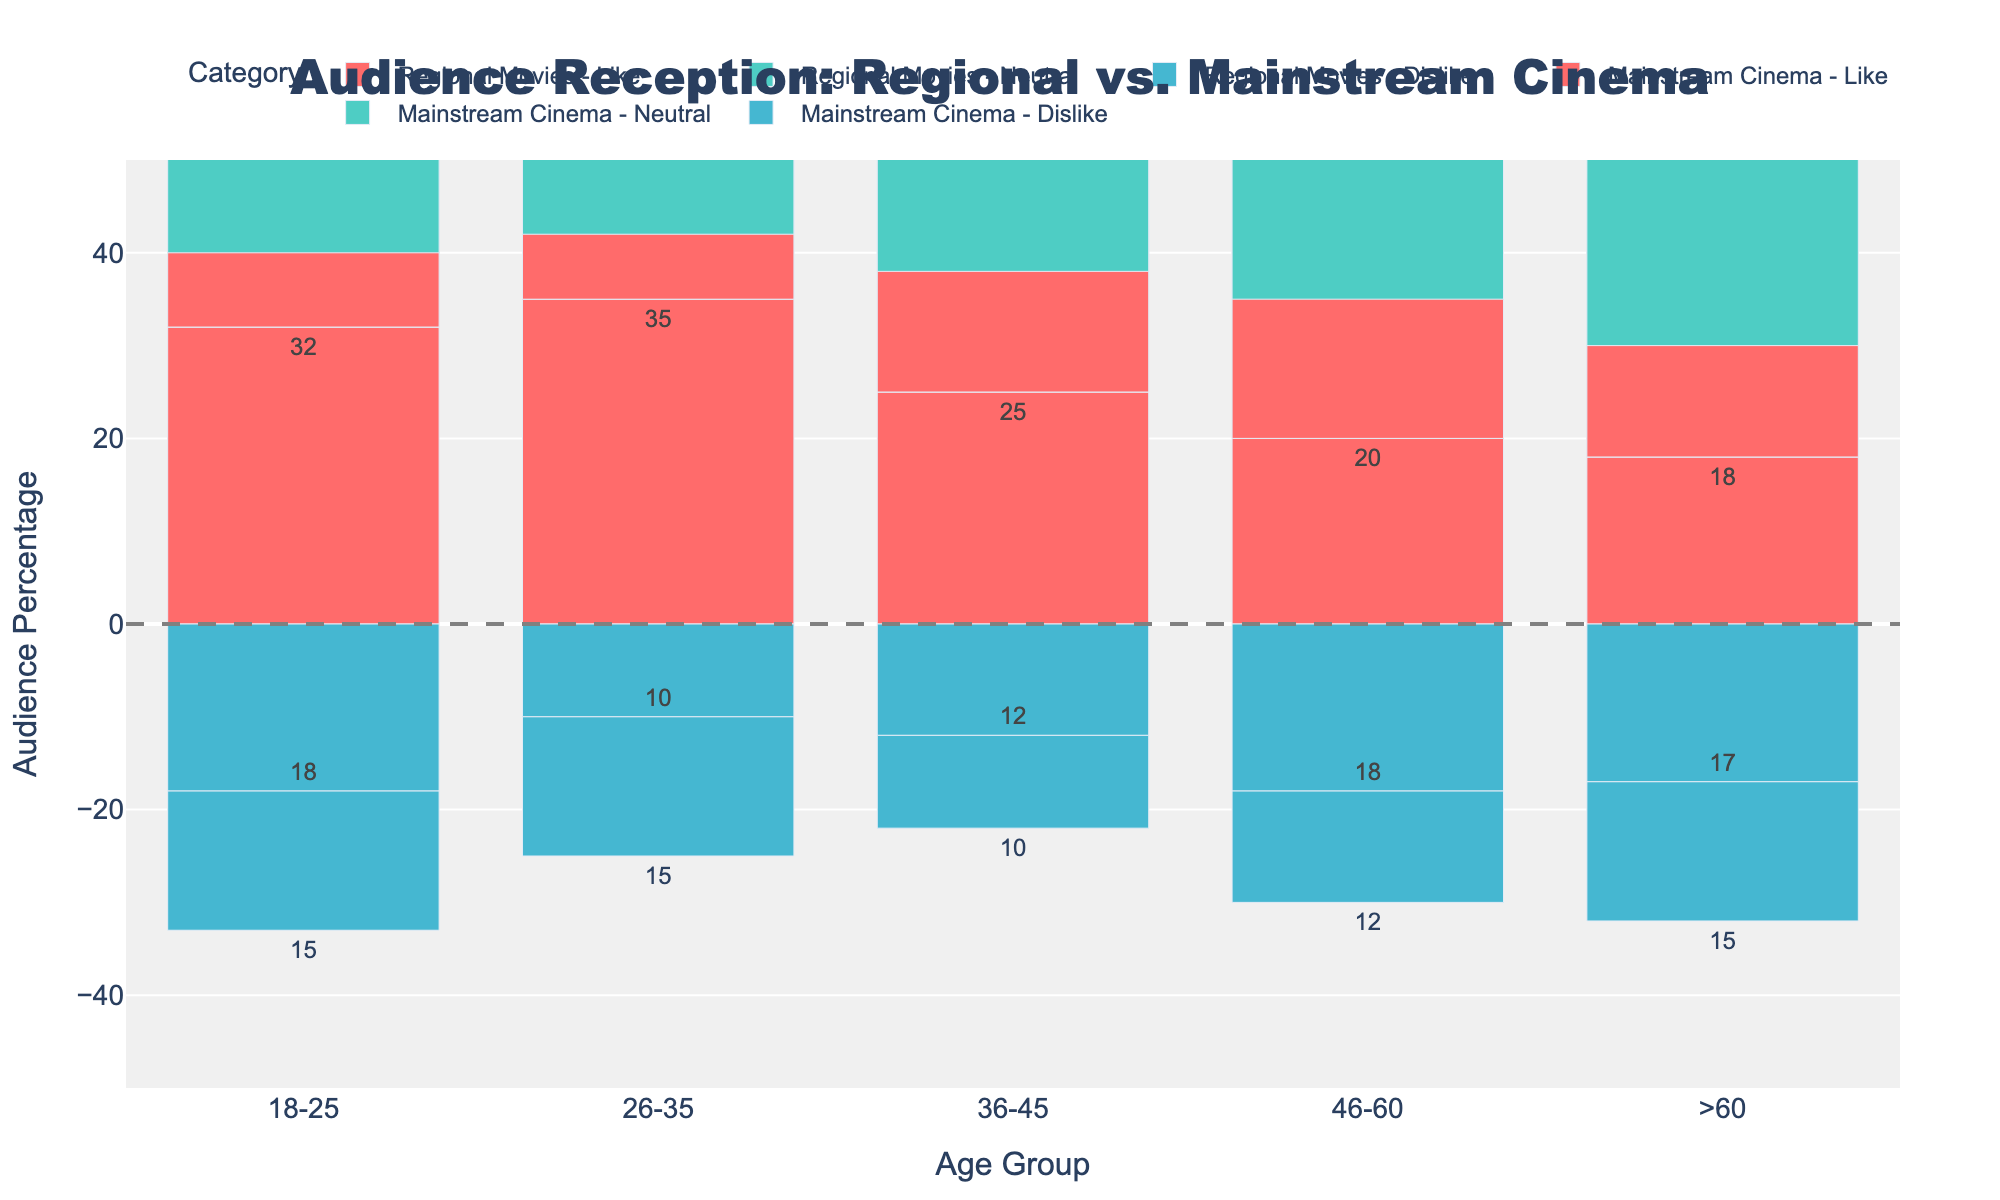Which age group has the highest percentage of 'Like' for Regional Movies? To find this, look at the bars representing 'Like' for Regional Movies across different age groups. The highest bar is for the 26-35 age group with a value of 35.
Answer: 26-35 Which category and age group had the least 'Dislike' ratings? Look at all the bars representing 'Dislike' ratings for both categories and age groups. The lowest bar for 'Dislike' is for Regional Movies in the 26-35 age group with a value of 10.
Answer: Regional Movies, 26-35 What is the difference in 'Like' percentage between Mainstream Cinema and Regional Movies for the 18-25 age group? Look at the 'Like' bars for both categories in the 18-25 age group. Mainstream Cinema has 40 and Regional Movies has 32. The difference is 40 - 32 = 8.
Answer: 8 Across all age groups, which category tends to have more 'Neutral' responses? Compare the height of 'Neutral' bars for Regional Movies and Mainstream Cinema across all age groups. Mainstream Cinema has higher 'Neutral' bars in most age groups.
Answer: Mainstream Cinema For the age group 46-60, what is the combined percentage of 'Like' and 'Neutral' for Mainstream Cinema? Look at the 'Like' and 'Neutral' bars for Mainstream Cinema in the 46-60 age group. 'Like' is 35 and 'Neutral' is 28, so the combined percentage is 35 + 28 = 63.
Answer: 63 Which age group shows the most balanced reception (i.e., closest percentages) for Regional Movies in terms of 'Like', 'Neutral', and 'Dislike'? Assess the similarity in heights of the 'Like', 'Neutral', and 'Dislike' bars for Regional Movies across age groups. The most balanced is the >60 age group with values 18, 25, and 17.
Answer: >60 Is there any age group where the 'Dislike' rating for Regional Movies is higher than for Mainstream Cinema? Compare 'Dislike' bars of both categories across all age groups. No age group has a higher 'Dislike' for Regional Movies than for Mainstream Cinema.
Answer: No Which category and age group combination received the highest number of 'Neutral' ratings? Identify the tallest 'Neutral' bar across all age groups and categories. The highest 'Neutral' bar is for Mainstream Cinema in the >60 age group with a value of 35.
Answer: Mainstream Cinema, >60 